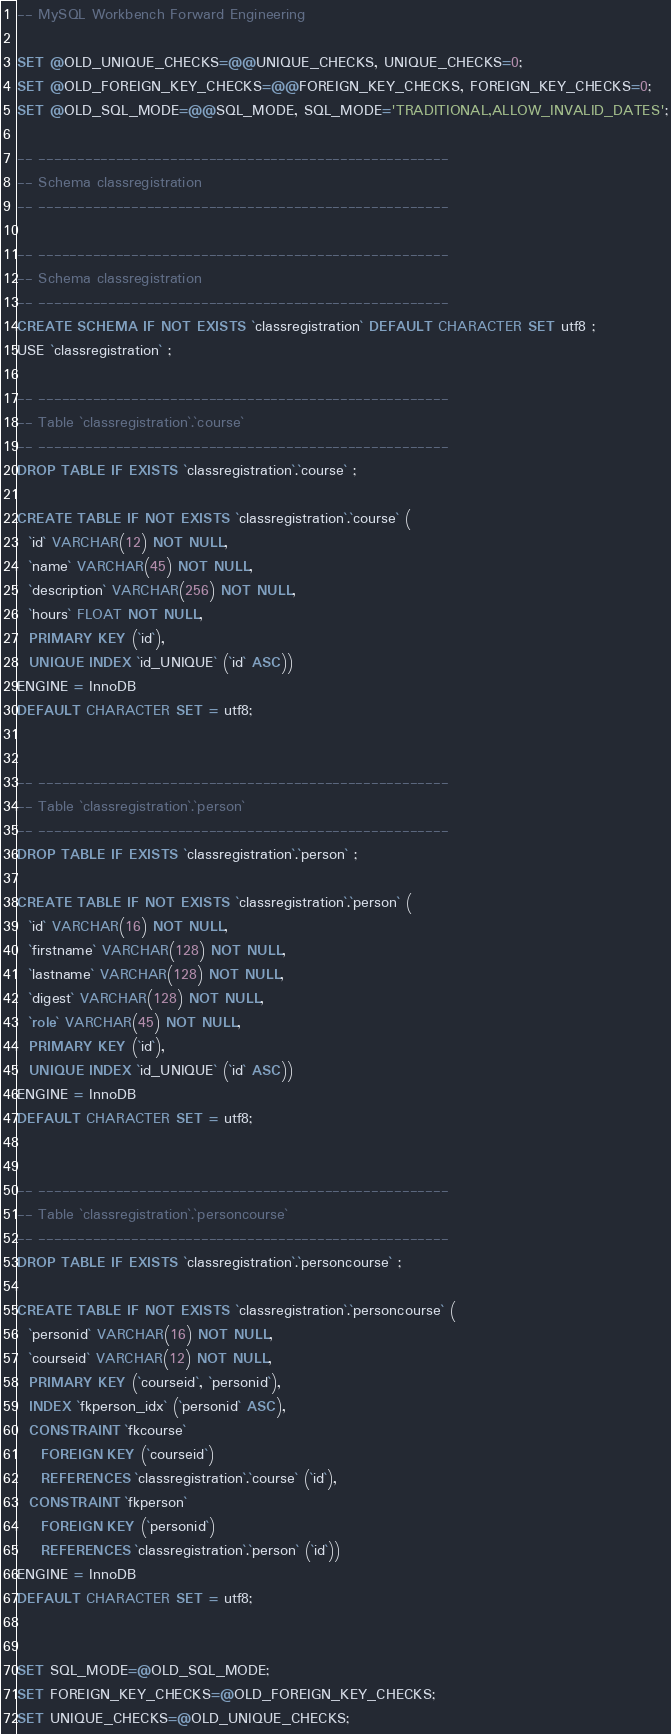Convert code to text. <code><loc_0><loc_0><loc_500><loc_500><_SQL_>-- MySQL Workbench Forward Engineering

SET @OLD_UNIQUE_CHECKS=@@UNIQUE_CHECKS, UNIQUE_CHECKS=0;
SET @OLD_FOREIGN_KEY_CHECKS=@@FOREIGN_KEY_CHECKS, FOREIGN_KEY_CHECKS=0;
SET @OLD_SQL_MODE=@@SQL_MODE, SQL_MODE='TRADITIONAL,ALLOW_INVALID_DATES';

-- -----------------------------------------------------
-- Schema classregistration
-- -----------------------------------------------------

-- -----------------------------------------------------
-- Schema classregistration
-- -----------------------------------------------------
CREATE SCHEMA IF NOT EXISTS `classregistration` DEFAULT CHARACTER SET utf8 ;
USE `classregistration` ;

-- -----------------------------------------------------
-- Table `classregistration`.`course`
-- -----------------------------------------------------
DROP TABLE IF EXISTS `classregistration`.`course` ;

CREATE TABLE IF NOT EXISTS `classregistration`.`course` (
  `id` VARCHAR(12) NOT NULL,
  `name` VARCHAR(45) NOT NULL,
  `description` VARCHAR(256) NOT NULL,
  `hours` FLOAT NOT NULL,
  PRIMARY KEY (`id`),
  UNIQUE INDEX `id_UNIQUE` (`id` ASC))
ENGINE = InnoDB
DEFAULT CHARACTER SET = utf8;


-- -----------------------------------------------------
-- Table `classregistration`.`person`
-- -----------------------------------------------------
DROP TABLE IF EXISTS `classregistration`.`person` ;

CREATE TABLE IF NOT EXISTS `classregistration`.`person` (
  `id` VARCHAR(16) NOT NULL,
  `firstname` VARCHAR(128) NOT NULL,
  `lastname` VARCHAR(128) NOT NULL,
  `digest` VARCHAR(128) NOT NULL,
  `role` VARCHAR(45) NOT NULL,
  PRIMARY KEY (`id`),
  UNIQUE INDEX `id_UNIQUE` (`id` ASC))
ENGINE = InnoDB
DEFAULT CHARACTER SET = utf8;


-- -----------------------------------------------------
-- Table `classregistration`.`personcourse`
-- -----------------------------------------------------
DROP TABLE IF EXISTS `classregistration`.`personcourse` ;

CREATE TABLE IF NOT EXISTS `classregistration`.`personcourse` (
  `personid` VARCHAR(16) NOT NULL,
  `courseid` VARCHAR(12) NOT NULL,
  PRIMARY KEY (`courseid`, `personid`),
  INDEX `fkperson_idx` (`personid` ASC),
  CONSTRAINT `fkcourse`
    FOREIGN KEY (`courseid`)
    REFERENCES `classregistration`.`course` (`id`),
  CONSTRAINT `fkperson`
    FOREIGN KEY (`personid`)
    REFERENCES `classregistration`.`person` (`id`))
ENGINE = InnoDB
DEFAULT CHARACTER SET = utf8;


SET SQL_MODE=@OLD_SQL_MODE;
SET FOREIGN_KEY_CHECKS=@OLD_FOREIGN_KEY_CHECKS;
SET UNIQUE_CHECKS=@OLD_UNIQUE_CHECKS;
</code> 